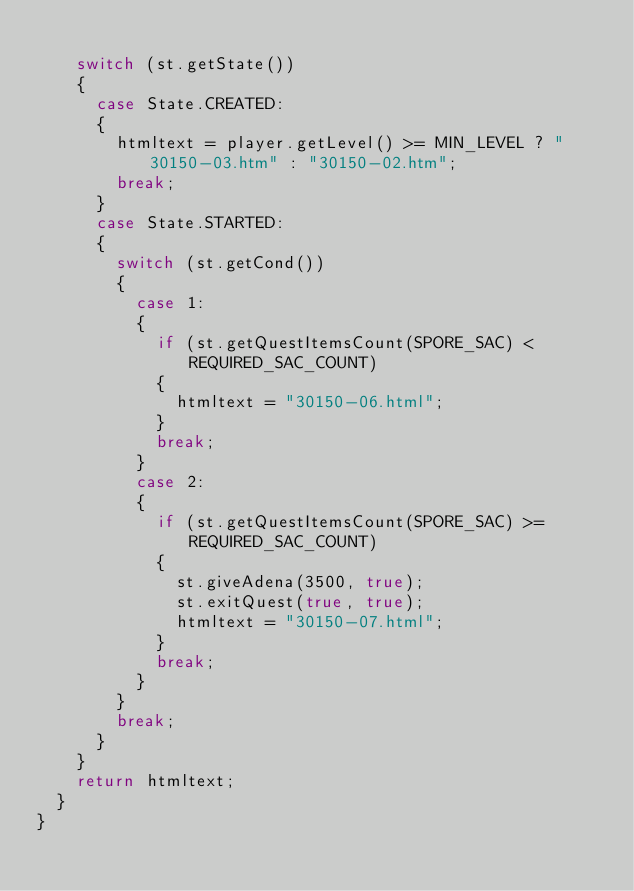Convert code to text. <code><loc_0><loc_0><loc_500><loc_500><_Java_>		
		switch (st.getState())
		{
			case State.CREATED:
			{
				htmltext = player.getLevel() >= MIN_LEVEL ? "30150-03.htm" : "30150-02.htm";
				break;
			}
			case State.STARTED:
			{
				switch (st.getCond())
				{
					case 1:
					{
						if (st.getQuestItemsCount(SPORE_SAC) < REQUIRED_SAC_COUNT)
						{
							htmltext = "30150-06.html";
						}
						break;
					}
					case 2:
					{
						if (st.getQuestItemsCount(SPORE_SAC) >= REQUIRED_SAC_COUNT)
						{
							st.giveAdena(3500, true);
							st.exitQuest(true, true);
							htmltext = "30150-07.html";
						}
						break;
					}
				}
				break;
			}
		}
		return htmltext;
	}
}</code> 